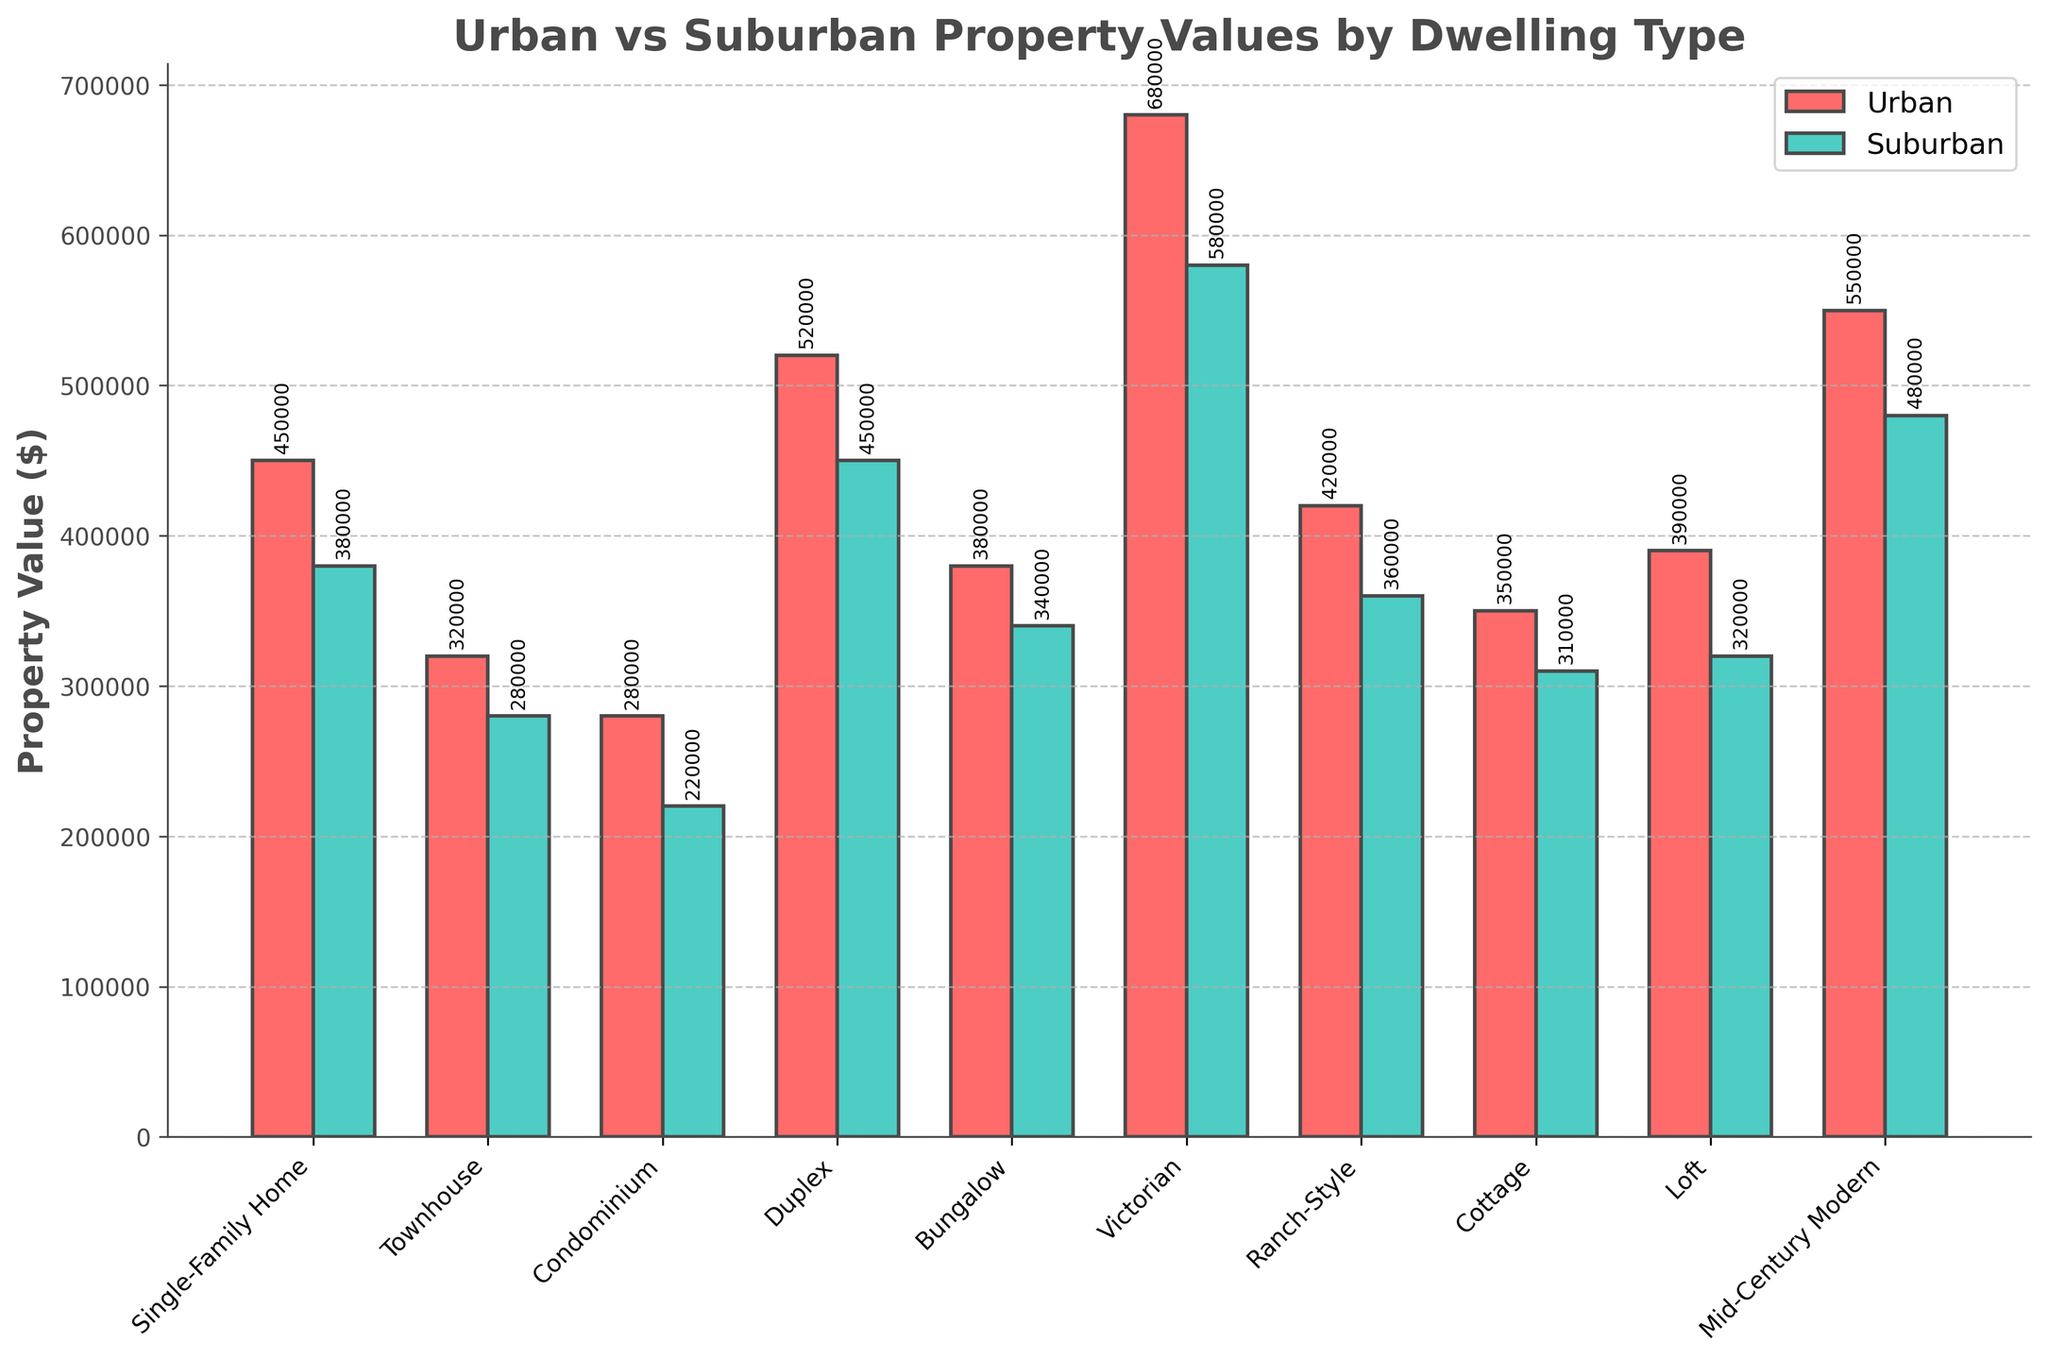Which property type has the highest urban value, and what is it? The Victorian property type has the highest urban value as indicated by the tallest red bar in the urban section of the graph.
Answer: Victorian, 680,000 How does the suburban value of a Single-Family Home compare to its urban value? The suburban value of a Single-Family Home is lower than its urban value. The bar for the Single-Family Home in the suburban section is shorter than the one in the urban section.
Answer: Suburban value is lower Which property type shows the smallest difference between its urban and suburban values? By observing the differences in the bar heights, the Condominium shows the smallest difference between its urban and suburban values.
Answer: Condominium What is the total property value for Bungalows if both urban and suburban areas are combined? To find the total property value for Bungalows, add the urban and suburban values: 380,000 (Urban) + 340,000 (Suburban) = 720,000.
Answer: 720,000 Which has a greater average property value in urban areas: Townhouses or Ranch-Style homes? To find the average property value, examine the height of the bars. The urban value for Townhouses is 320,000 and for Ranch-Style homes is 420,000. Since the bars indicate that Ranch-Style homes have a higher property value, the average is greater for Ranch-Style homes.
Answer: Ranch-Style homes What's the difference between the suburban and urban value for a Victorian property? Subtract the suburban value from the urban value for a Victorian property: 680,000 (Urban) - 580,000 (Suburban) = 100,000.
Answer: 100,000 How does the urban property value of a Loft compare to a Cottage in suburban areas? The urban property value of a Loft is higher than that of a Cottage in suburban areas, which can be seen from the height of the respective bars: 390,000 for Loft (Urban) versus 310,000 for Cottage (Suburban).
Answer: Loft is higher What is the combined property value of the most expensive urban and suburban properties? Identify the highest values in both urban and suburban areas: Victorian (Urban) at 680,000 and Victorian (Suburban) at 580,000. Their combined value is 680,000 + 580,000 = 1,260,000.
Answer: 1,260,000 Which property type in suburban areas has a value closest to 300,000? By examining the bar heights, the Cottage in the suburban area has a value of 310,000, which is closest to 300,000.
Answer: Cottage 